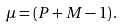Convert formula to latex. <formula><loc_0><loc_0><loc_500><loc_500>\mu = \left ( P + M - 1 \right ) .</formula> 